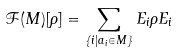Convert formula to latex. <formula><loc_0><loc_0><loc_500><loc_500>\mathcal { F } ( M ) [ \rho ] = \sum _ { \{ i | a _ { i } \in M \} } E _ { i } \rho E _ { i }</formula> 